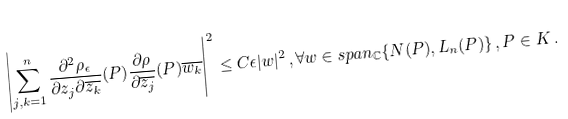Convert formula to latex. <formula><loc_0><loc_0><loc_500><loc_500>\left | \sum _ { j , k = 1 } ^ { n } \frac { \partial ^ { 2 } \rho _ { \epsilon } } { \partial z _ { j } \partial \overline { z _ { k } } } ( P ) \frac { \partial \rho } { \partial \overline { z _ { j } } } ( P ) \overline { w _ { k } } \right | ^ { 2 } \leq C \epsilon | w | ^ { 2 } \, , \forall w \in s p a n _ { \mathbb { C } } \{ N ( P ) , L _ { n } ( P ) \} \, , P \in K \, .</formula> 